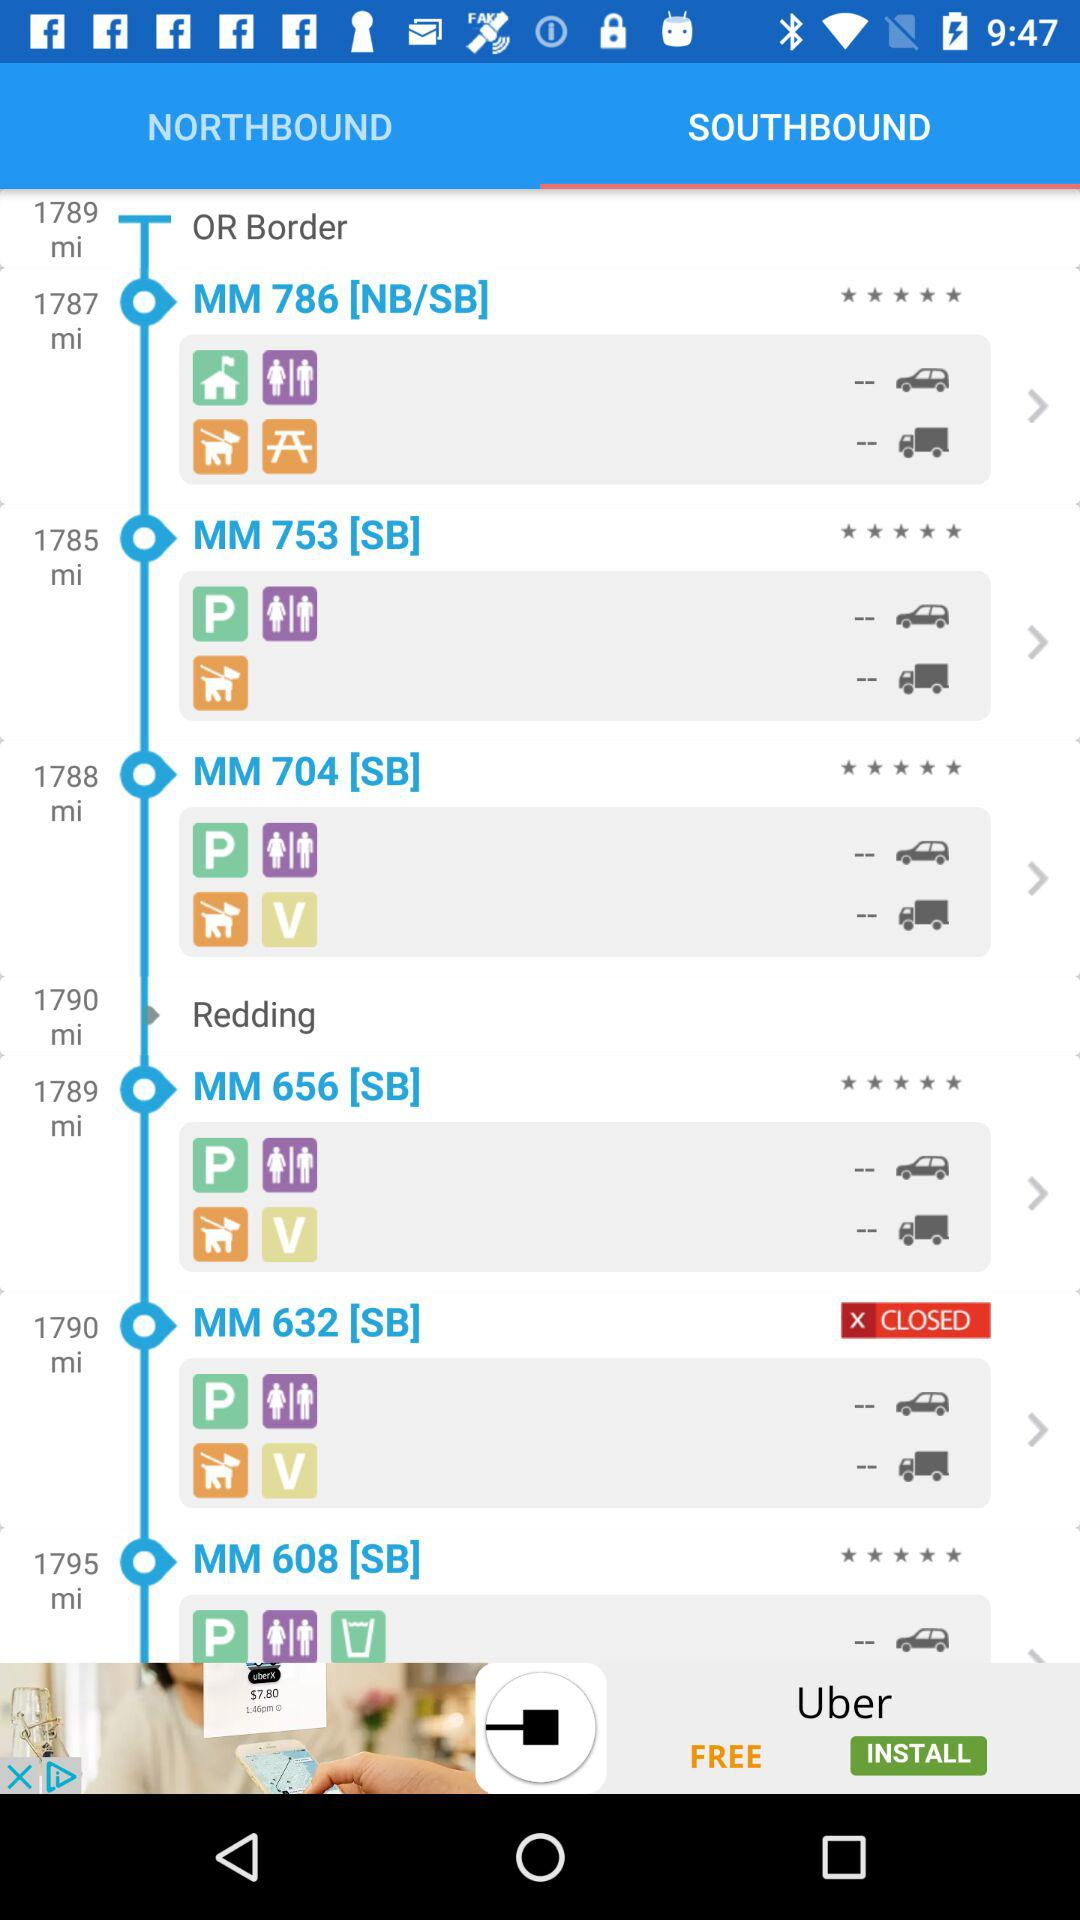What tab has been selected? The selected tab is "SOUTHBOUND". 